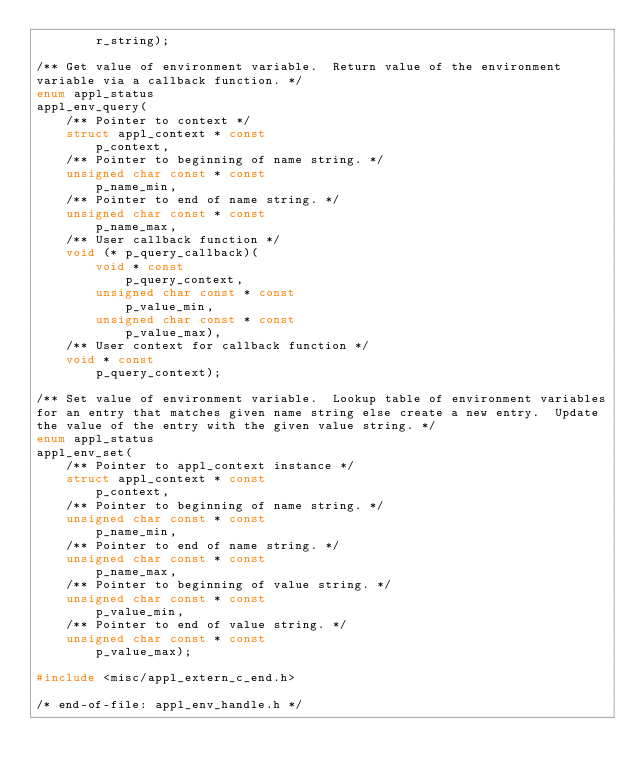<code> <loc_0><loc_0><loc_500><loc_500><_C_>        r_string);

/** Get value of environment variable.  Return value of the environment
variable via a callback function. */
enum appl_status
appl_env_query(
    /** Pointer to context */
    struct appl_context * const
        p_context,
    /** Pointer to beginning of name string. */
    unsigned char const * const
        p_name_min,
    /** Pointer to end of name string. */
    unsigned char const * const
        p_name_max,
    /** User callback function */
    void (* p_query_callback)(
        void * const
            p_query_context,
        unsigned char const * const
            p_value_min,
        unsigned char const * const
            p_value_max),
    /** User context for callback function */
    void * const
        p_query_context);

/** Set value of environment variable.  Lookup table of environment variables
for an entry that matches given name string else create a new entry.  Update
the value of the entry with the given value string. */
enum appl_status
appl_env_set(
    /** Pointer to appl_context instance */
    struct appl_context * const
        p_context,
    /** Pointer to beginning of name string. */
    unsigned char const * const
        p_name_min,
    /** Pointer to end of name string. */
    unsigned char const * const
        p_name_max,
    /** Pointer to beginning of value string. */
    unsigned char const * const
        p_value_min,
    /** Pointer to end of value string. */
    unsigned char const * const
        p_value_max);

#include <misc/appl_extern_c_end.h>

/* end-of-file: appl_env_handle.h */
</code> 